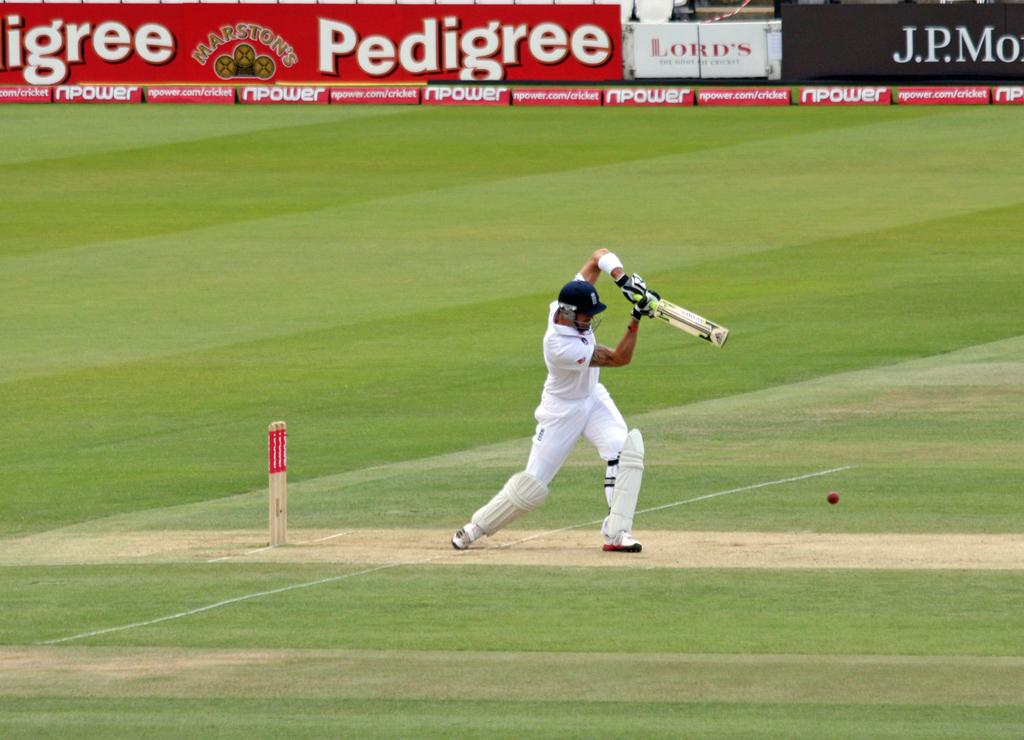<image>
Present a compact description of the photo's key features. An ad for Pedigree lines a baseball field next to a J.P. Morgan ad 